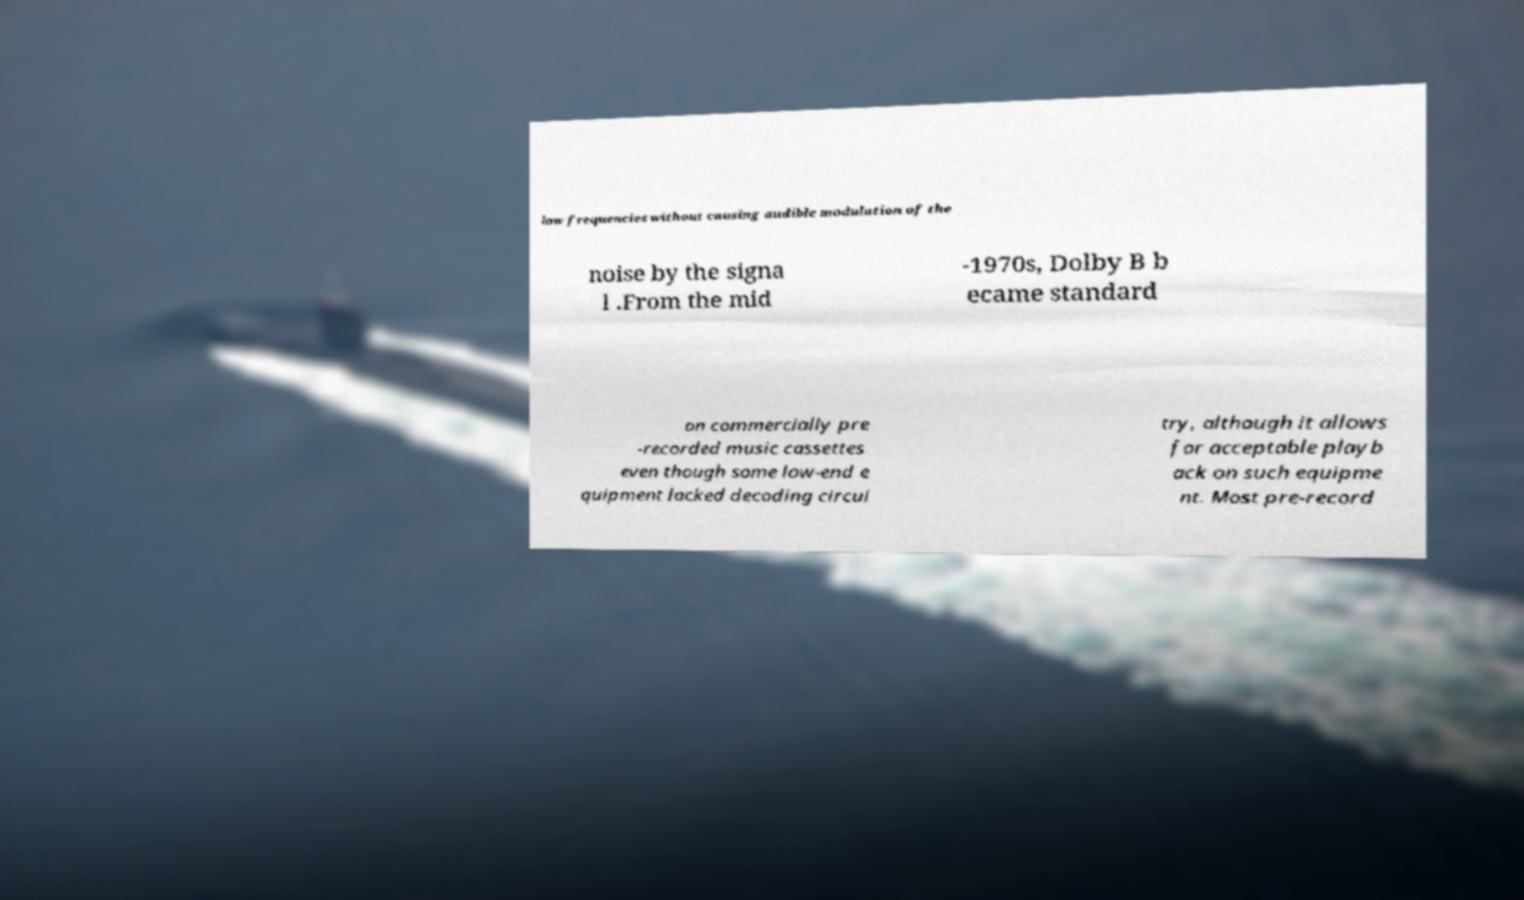For documentation purposes, I need the text within this image transcribed. Could you provide that? low frequencies without causing audible modulation of the noise by the signa l .From the mid -1970s, Dolby B b ecame standard on commercially pre -recorded music cassettes even though some low-end e quipment lacked decoding circui try, although it allows for acceptable playb ack on such equipme nt. Most pre-record 